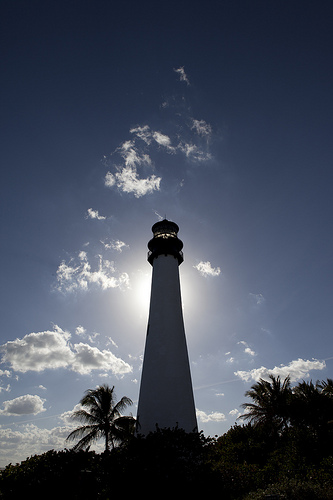<image>
Is the lighthouse under the sun? Yes. The lighthouse is positioned underneath the sun, with the sun above it in the vertical space. 